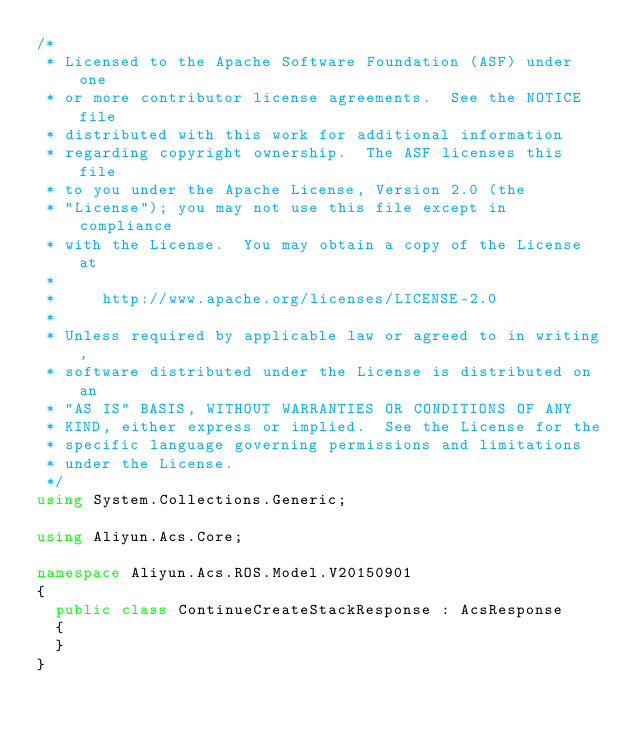<code> <loc_0><loc_0><loc_500><loc_500><_C#_>/*
 * Licensed to the Apache Software Foundation (ASF) under one
 * or more contributor license agreements.  See the NOTICE file
 * distributed with this work for additional information
 * regarding copyright ownership.  The ASF licenses this file
 * to you under the Apache License, Version 2.0 (the
 * "License"); you may not use this file except in compliance
 * with the License.  You may obtain a copy of the License at
 *
 *     http://www.apache.org/licenses/LICENSE-2.0
 *
 * Unless required by applicable law or agreed to in writing,
 * software distributed under the License is distributed on an
 * "AS IS" BASIS, WITHOUT WARRANTIES OR CONDITIONS OF ANY
 * KIND, either express or implied.  See the License for the
 * specific language governing permissions and limitations
 * under the License.
 */
using System.Collections.Generic;

using Aliyun.Acs.Core;

namespace Aliyun.Acs.ROS.Model.V20150901
{
	public class ContinueCreateStackResponse : AcsResponse
	{
	}
}
</code> 